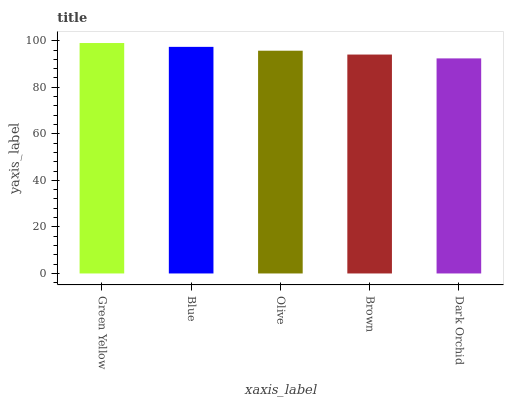Is Dark Orchid the minimum?
Answer yes or no. Yes. Is Green Yellow the maximum?
Answer yes or no. Yes. Is Blue the minimum?
Answer yes or no. No. Is Blue the maximum?
Answer yes or no. No. Is Green Yellow greater than Blue?
Answer yes or no. Yes. Is Blue less than Green Yellow?
Answer yes or no. Yes. Is Blue greater than Green Yellow?
Answer yes or no. No. Is Green Yellow less than Blue?
Answer yes or no. No. Is Olive the high median?
Answer yes or no. Yes. Is Olive the low median?
Answer yes or no. Yes. Is Green Yellow the high median?
Answer yes or no. No. Is Blue the low median?
Answer yes or no. No. 